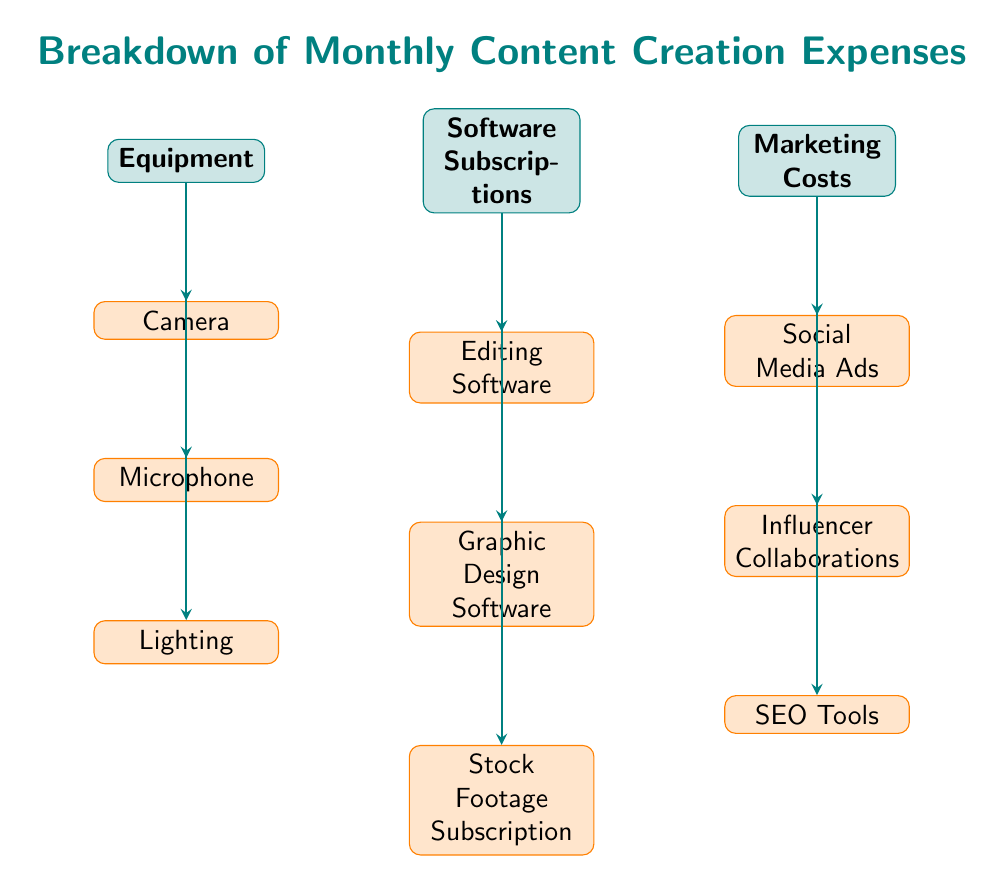What are the main categories of monthly content creation expenses? The diagram lists three main categories: Equipment, Software Subscriptions, and Marketing Costs.
Answer: Equipment, Software Subscriptions, Marketing Costs How many subcategories are listed under Equipment? The diagram shows three subcategories under Equipment: Camera, Microphone, and Lighting.
Answer: 3 What is the last subcategory listed under Software Subscriptions? The final subcategory under Software Subscriptions is Stock Footage Subscription, which is the last node positioned below Graphic Design Software.
Answer: Stock Footage Subscription Which main category has the highest number of subcategories? Upon examining the diagram, Marketing Costs has three subcategories (Social Media Ads, Influencer Collaborations, and SEO Tools), equal to Equipment and Software Subscriptions, but noting that all three main categories have the same count.
Answer: None Identify the relationship between Marketing Costs and Influencer Collaborations. The relationship is shown with a directed arrow from Marketing Costs to Influencer Collaborations, indicating that Influencer Collaborations is a subcategory under Marketing Costs.
Answer: Subcategory What do all subcategories under Equipment have in common? All subcategories under Equipment are tools or devices used for enhancing content quality, which are crucial for content creation purposes.
Answer: Enhancing content quality Which main category would you check to find editing tools? Editing tools are located under the Software Subscriptions main category, where Editing Software is listed as one of the subcategories.
Answer: Software Subscriptions If you had to cut costs, which area would you likely reduce first? The decision may vary depending on personal priorities, but typically many vloggers might consider reducing Marketing Costs to save money initially.
Answer: Marketing Costs What does the overall title of the diagram indicate about the content? The title 'Breakdown of Monthly Content Creation Expenses' indicates that the diagram provides an organized visual representation of the different expense categories related to creating content on a monthly basis.
Answer: Monthly expenses 